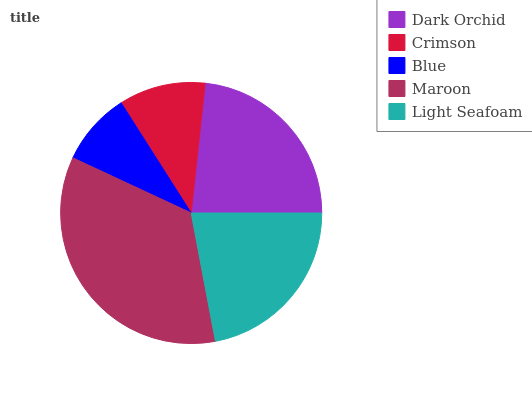Is Blue the minimum?
Answer yes or no. Yes. Is Maroon the maximum?
Answer yes or no. Yes. Is Crimson the minimum?
Answer yes or no. No. Is Crimson the maximum?
Answer yes or no. No. Is Dark Orchid greater than Crimson?
Answer yes or no. Yes. Is Crimson less than Dark Orchid?
Answer yes or no. Yes. Is Crimson greater than Dark Orchid?
Answer yes or no. No. Is Dark Orchid less than Crimson?
Answer yes or no. No. Is Light Seafoam the high median?
Answer yes or no. Yes. Is Light Seafoam the low median?
Answer yes or no. Yes. Is Blue the high median?
Answer yes or no. No. Is Dark Orchid the low median?
Answer yes or no. No. 